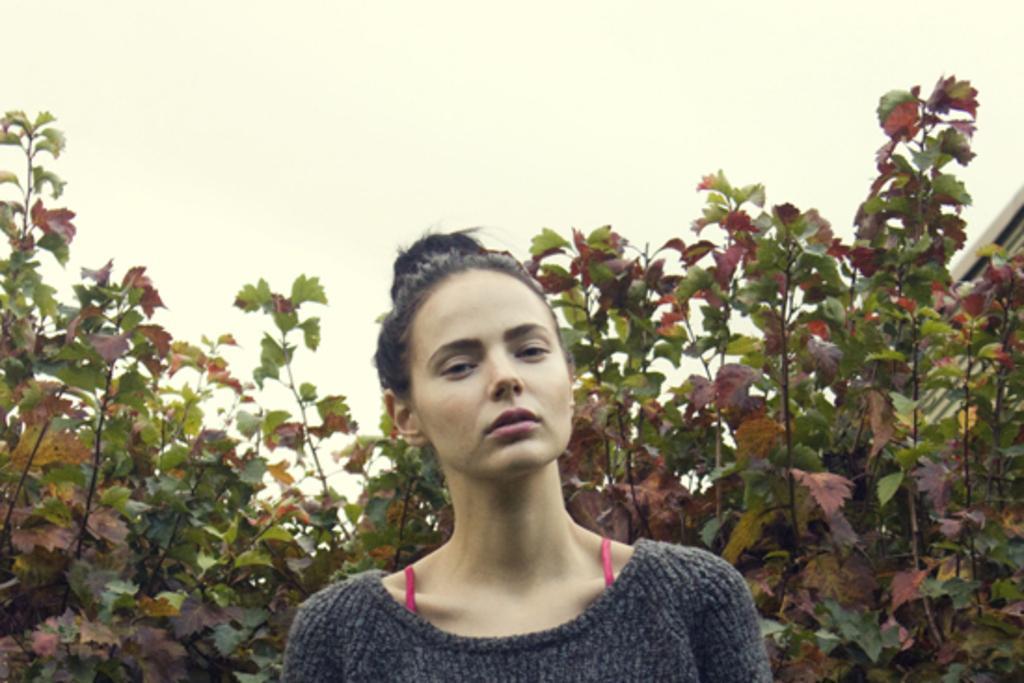How would you summarize this image in a sentence or two? In this picture we can observe a woman wearing a grey color sweatshirt. There are some plants behind her. In the background there is a sky. 